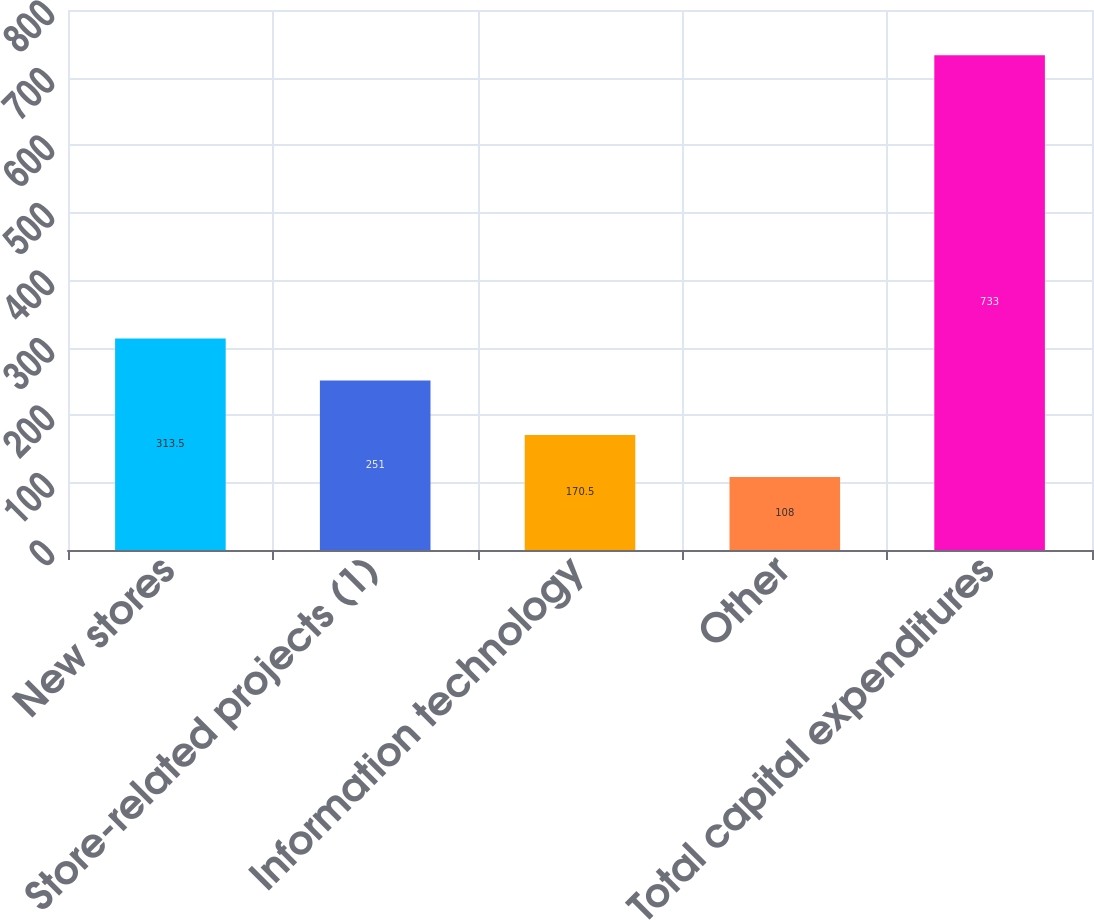Convert chart. <chart><loc_0><loc_0><loc_500><loc_500><bar_chart><fcel>New stores<fcel>Store-related projects (1)<fcel>Information technology<fcel>Other<fcel>Total capital expenditures<nl><fcel>313.5<fcel>251<fcel>170.5<fcel>108<fcel>733<nl></chart> 